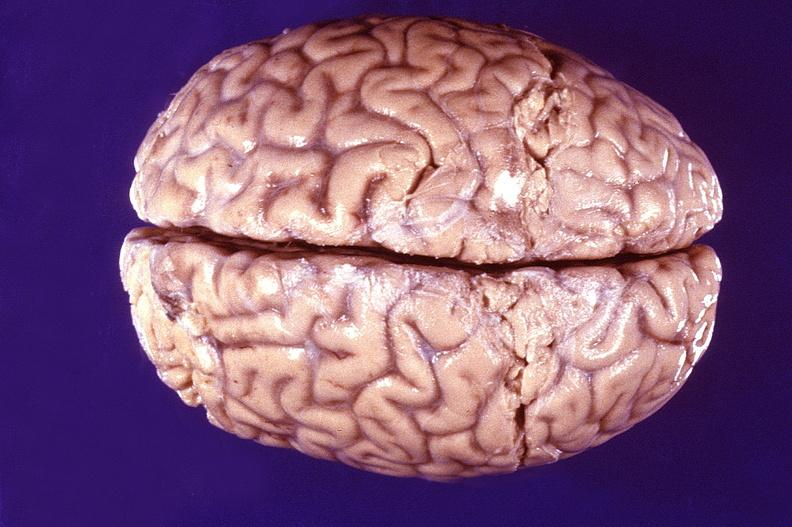does stomach show normal brain?
Answer the question using a single word or phrase. No 